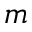<formula> <loc_0><loc_0><loc_500><loc_500>m</formula> 